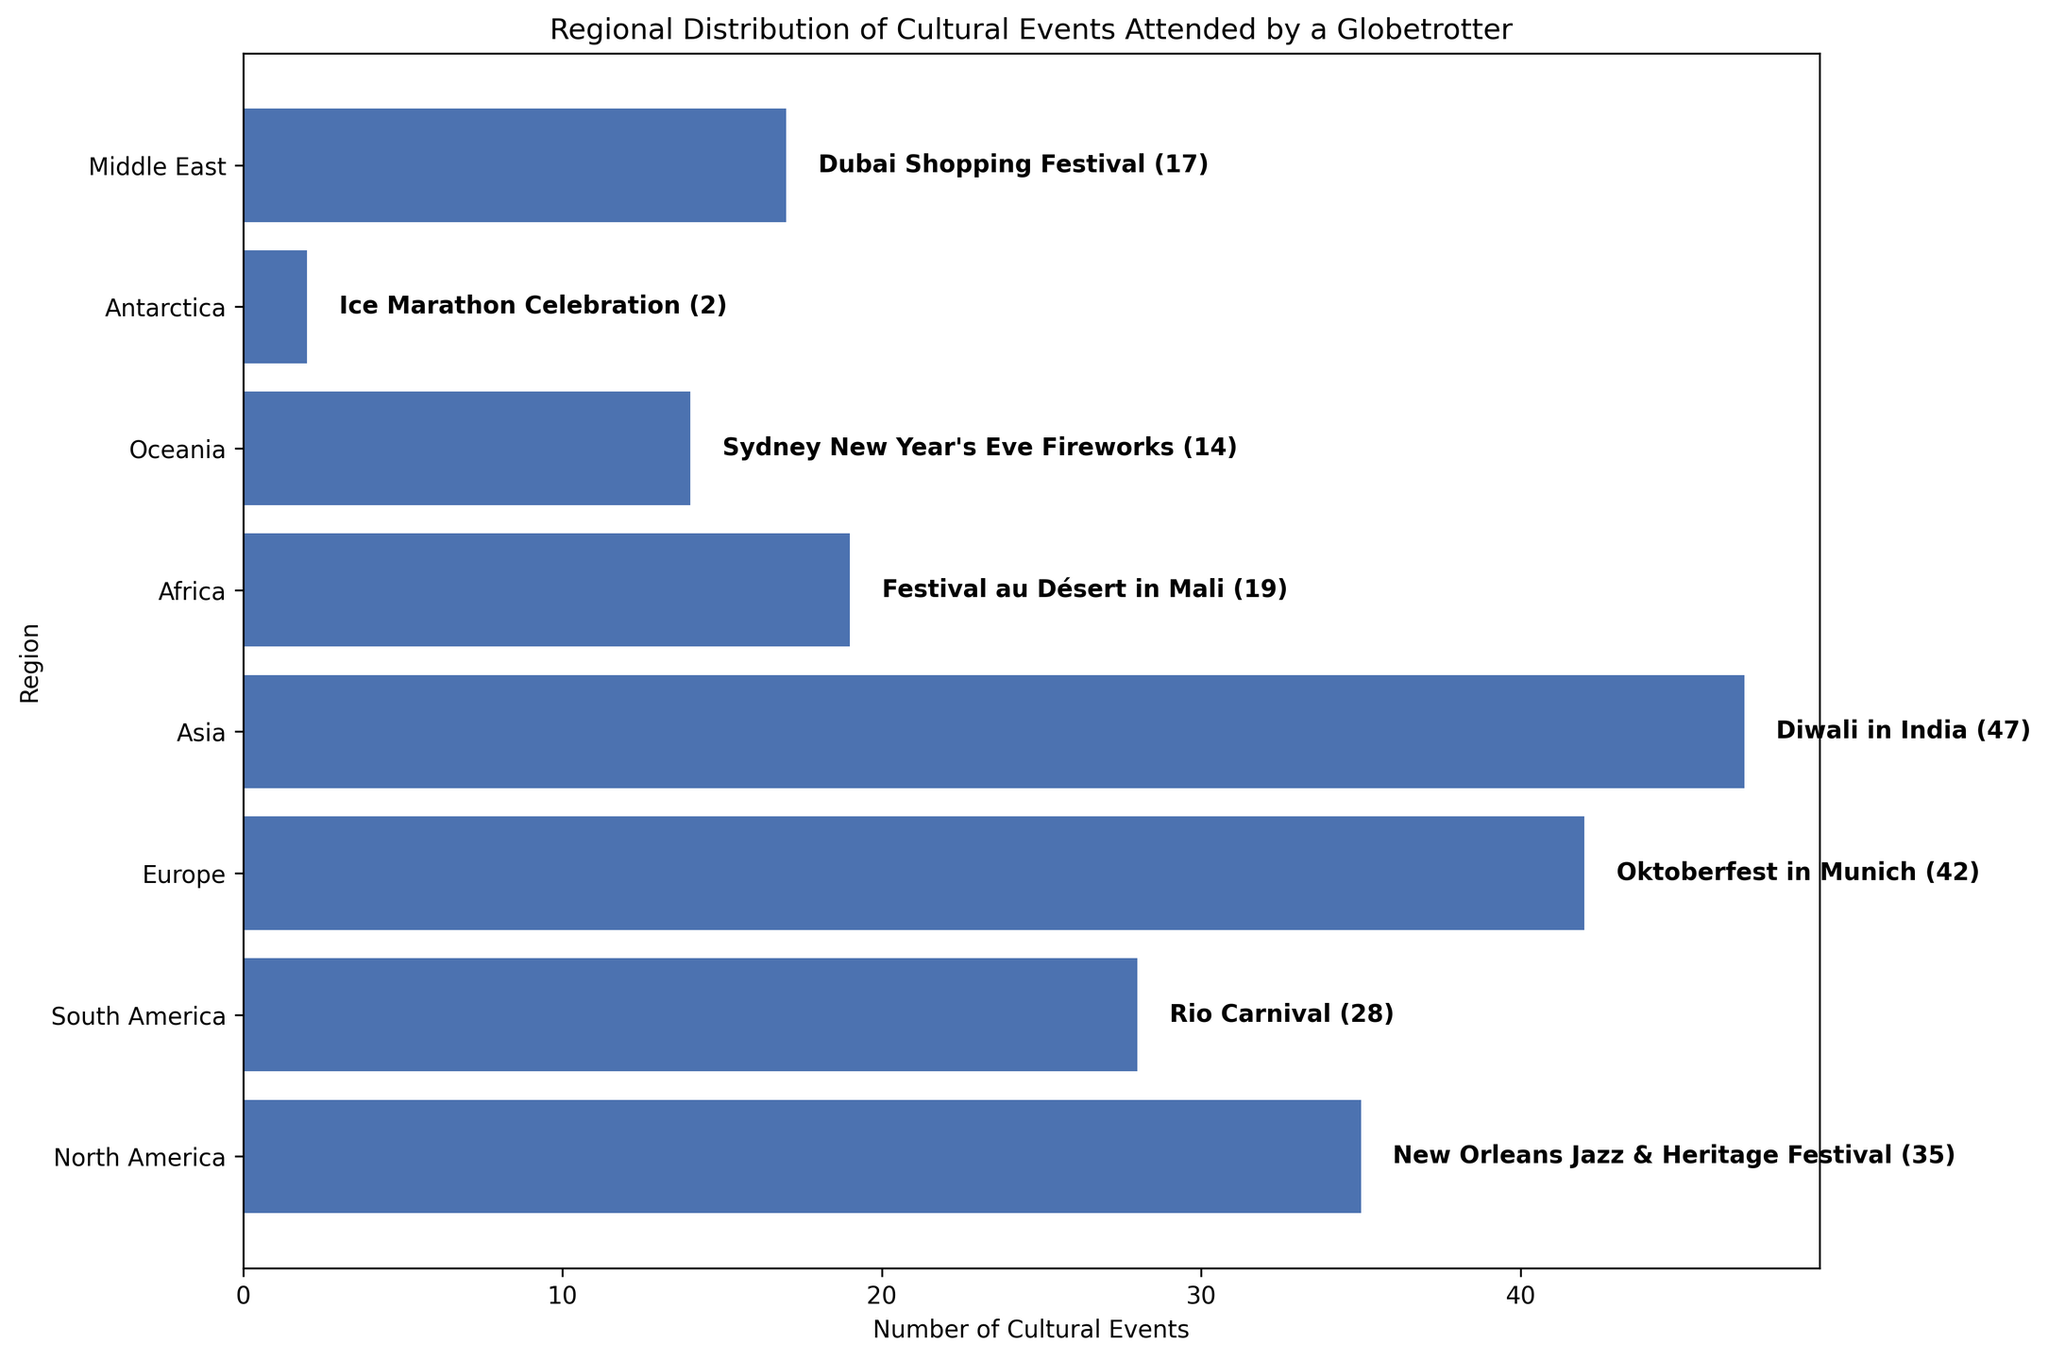What's the most memorable event in Asia? The figure shows that Diwali in India is highlighted as the most memorable event in Asia.
Answer: Diwali in India Which region has the highest number of cultural events attended? By comparing the lengths of the bars, the region with the longest bar represents the highest number of cultural events. Asia has the longest bar with 47 events.
Answer: Asia How many more cultural events were attended in Europe compared to Africa? The number of cultural events in Europe is 42, and in Africa, it is 19. The difference is calculated as 42 - 19.
Answer: 23 What is the total number of cultural events attended in Oceania and Antarctica? The number of cultural events in Oceania is 14, and in Antarctica, it is 2. The sum of these is 14 + 2.
Answer: 16 Which event was the most memorable in North America? The annotation next to North America's bar states that the most memorable event was the New Orleans Jazz & Heritage Festival.
Answer: New Orleans Jazz & Heritage Festival Which region has a higher number of cultural events, the Middle East or South America? By comparing the lengths of the bars, the Middle East has 17 events, and South America has 28 events. South America's bar is longer.
Answer: South America Calculate the average number of cultural events attended across all regions. The total number of events is the sum of each region's events (35 + 28 + 42 + 47 + 19 + 14 + 2 + 17 = 204). There are 8 regions, so the average is 204 / 8.
Answer: 25.5 What's the most memorable event in Australia and which region is it located in? The most memorable event in Oceania, which includes Australia, is the Sydney New Year's Eve Fireworks.
Answer: Sydney New Year's Eve Fireworks, Oceania By how much does the number of cultural events attended in Asia exceed that in North America? The number of cultural events in Asia is 47, and in North America, it is 35. The difference is calculated as 47 - 35.
Answer: 12 